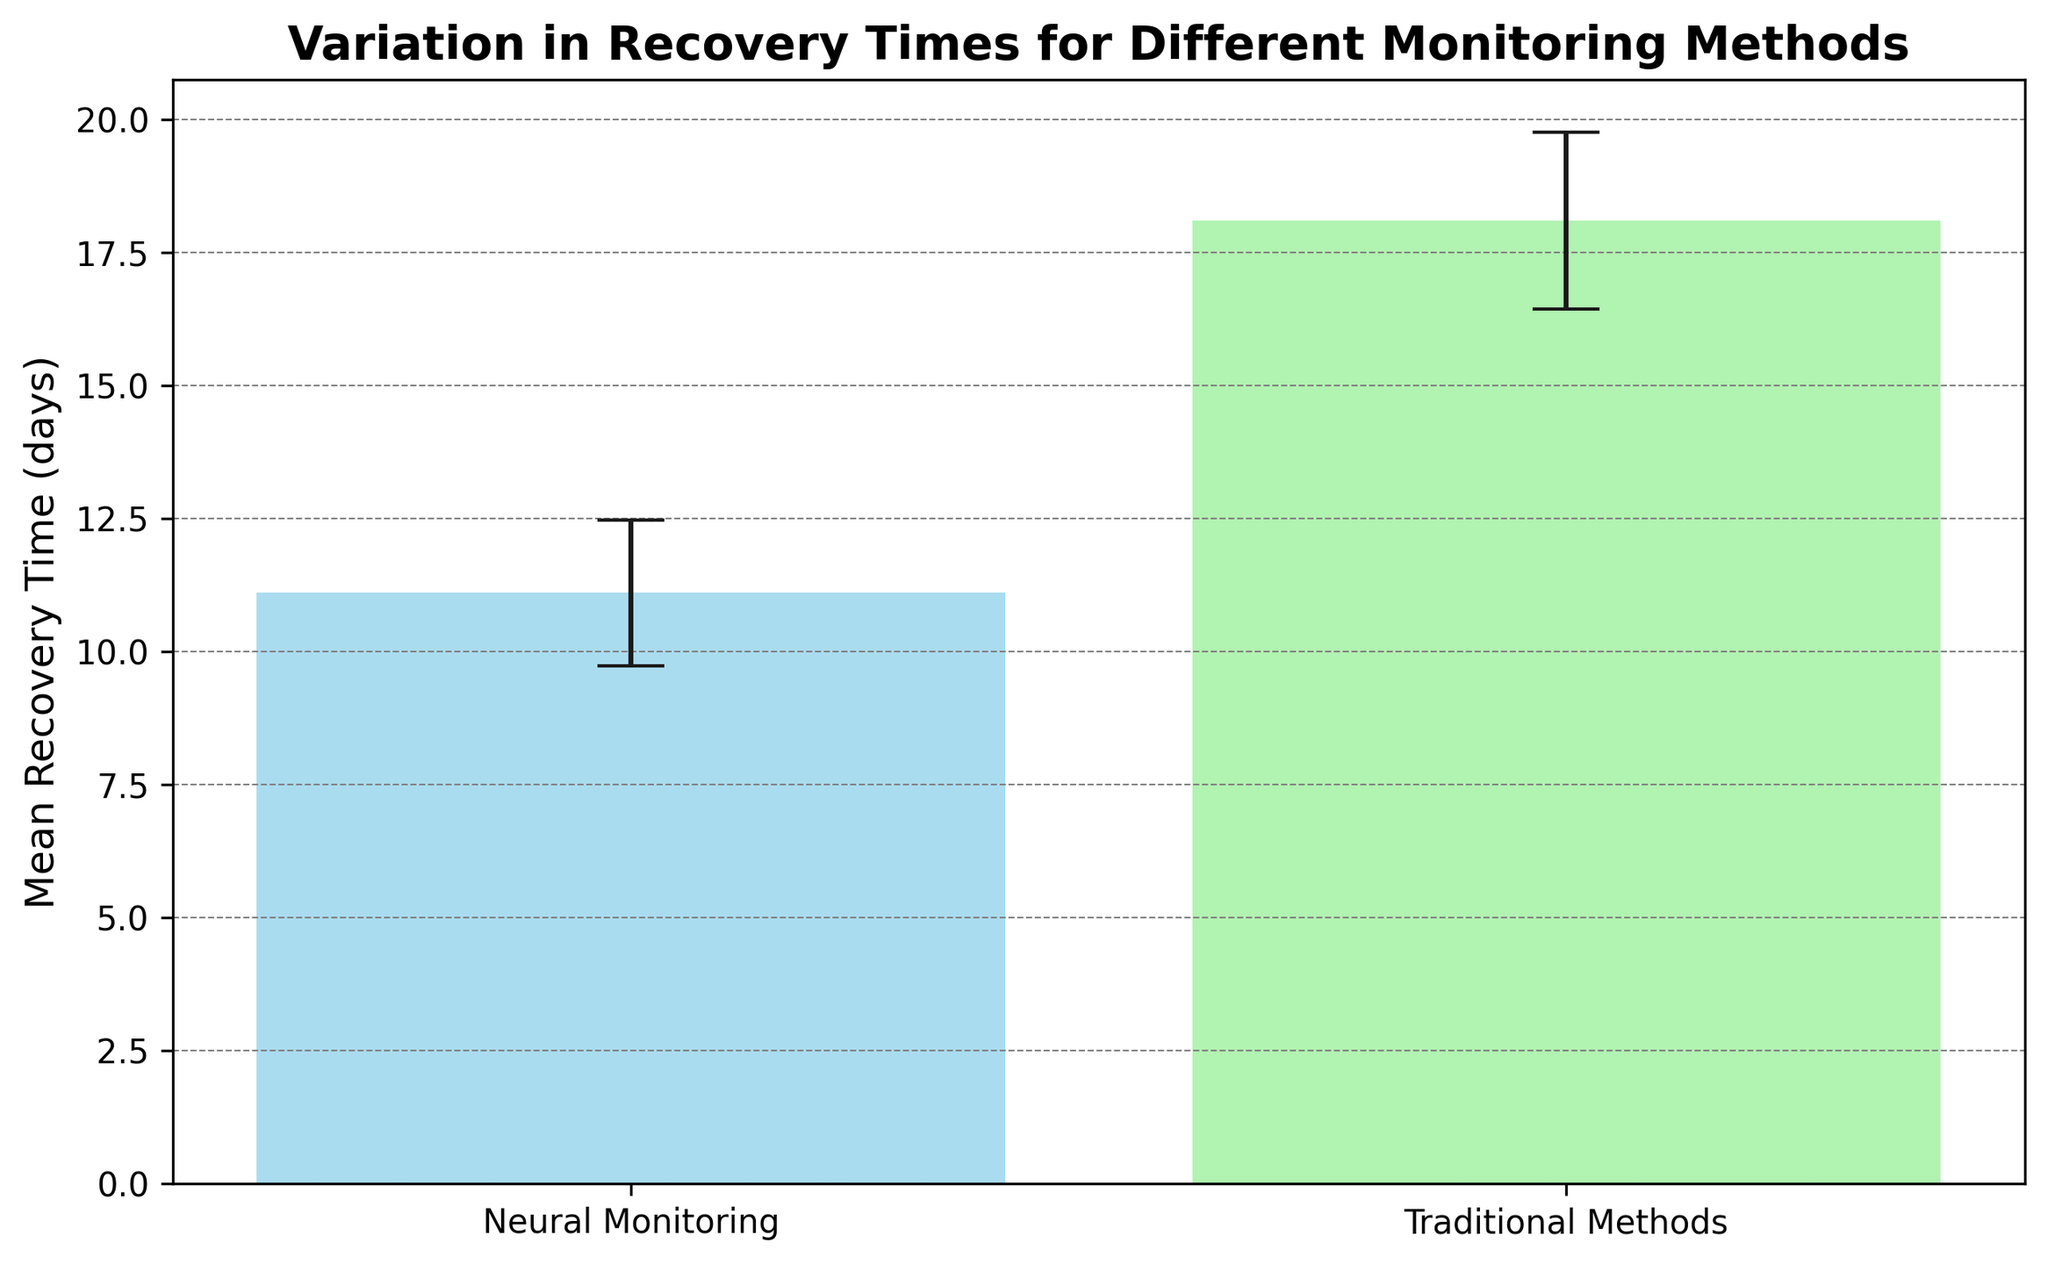What is the mean recovery time for patients using neural monitoring techniques? From the figure, look at the bar height for the 'Neural Monitoring' method, which represents the mean recovery time for this method.
Answer: 11 days What is the mean recovery time for patients using traditional methods? From the figure, observe the bar height for the 'Traditional Methods' method, which shows the mean recovery time for this method.
Answer: 18 days Which monitoring method has a shorter mean recovery time? Compare the heights of the bars representing the mean recovery times for both 'Neural Monitoring' and 'Traditional Methods.' The 'Neural Monitoring' bar is shorter.
Answer: Neural Monitoring By how many days is the mean recovery time for neural monitoring shorter than traditional methods? Subtract the height of the 'Neural Monitoring' bar from the height of the 'Traditional Methods' bar (18 - 11).
Answer: 7 days What is the standard deviation for recovery times under traditional methods? Look at the error bar (whisker) on top of the 'Traditional Methods' bar, which represents the standard deviation.
Answer: Approximately 1.58 days How does the variability in recovery times compare between the two methods? Compare the length of the error bars (whiskers) on top of each method's bar. The longer the error bar, the higher the variability. The 'Traditional Methods' has a slightly longer error bar.
Answer: Traditional Methods have higher variability What is the total recovery time for patients using neural monitoring if each patient took the average time shown? Multiply the mean recovery time for neural monitoring (11 days) by the number of patients (10).
Answer: 110 days Which method has greater variability in recovery times based on the bar's error lengths? Compare the lengths of the error bars for both methods. The error bar for 'Traditional Methods' is visually longer, indicating greater variability.
Answer: Traditional Methods Considering the standard deviations, which method would you say is more consistent in recovery times? A smaller standard deviation indicates more consistency. As 'Neural Monitoring' has a smaller error bar (standard deviation), it shows more consistent recovery times.
Answer: Neural Monitoring What is the difference in standard deviations between the two methods? Calculate the difference between the standard deviations of the two methods (σ_Traditional - σ_Neural). Looking at the error bars, the standard deviation appears roughly as 1.58 for Traditional and about 1.29 for Neural.
Answer: Approximately 0.29 days 